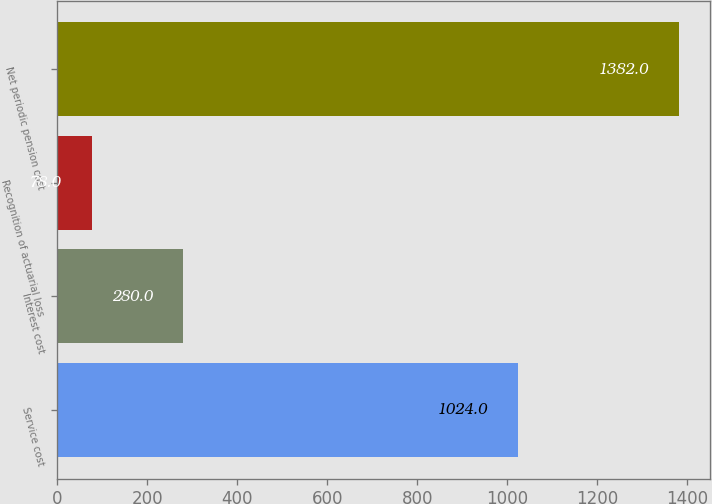Convert chart to OTSL. <chart><loc_0><loc_0><loc_500><loc_500><bar_chart><fcel>Service cost<fcel>Interest cost<fcel>Recognition of actuarial loss<fcel>Net periodic pension cost<nl><fcel>1024<fcel>280<fcel>78<fcel>1382<nl></chart> 